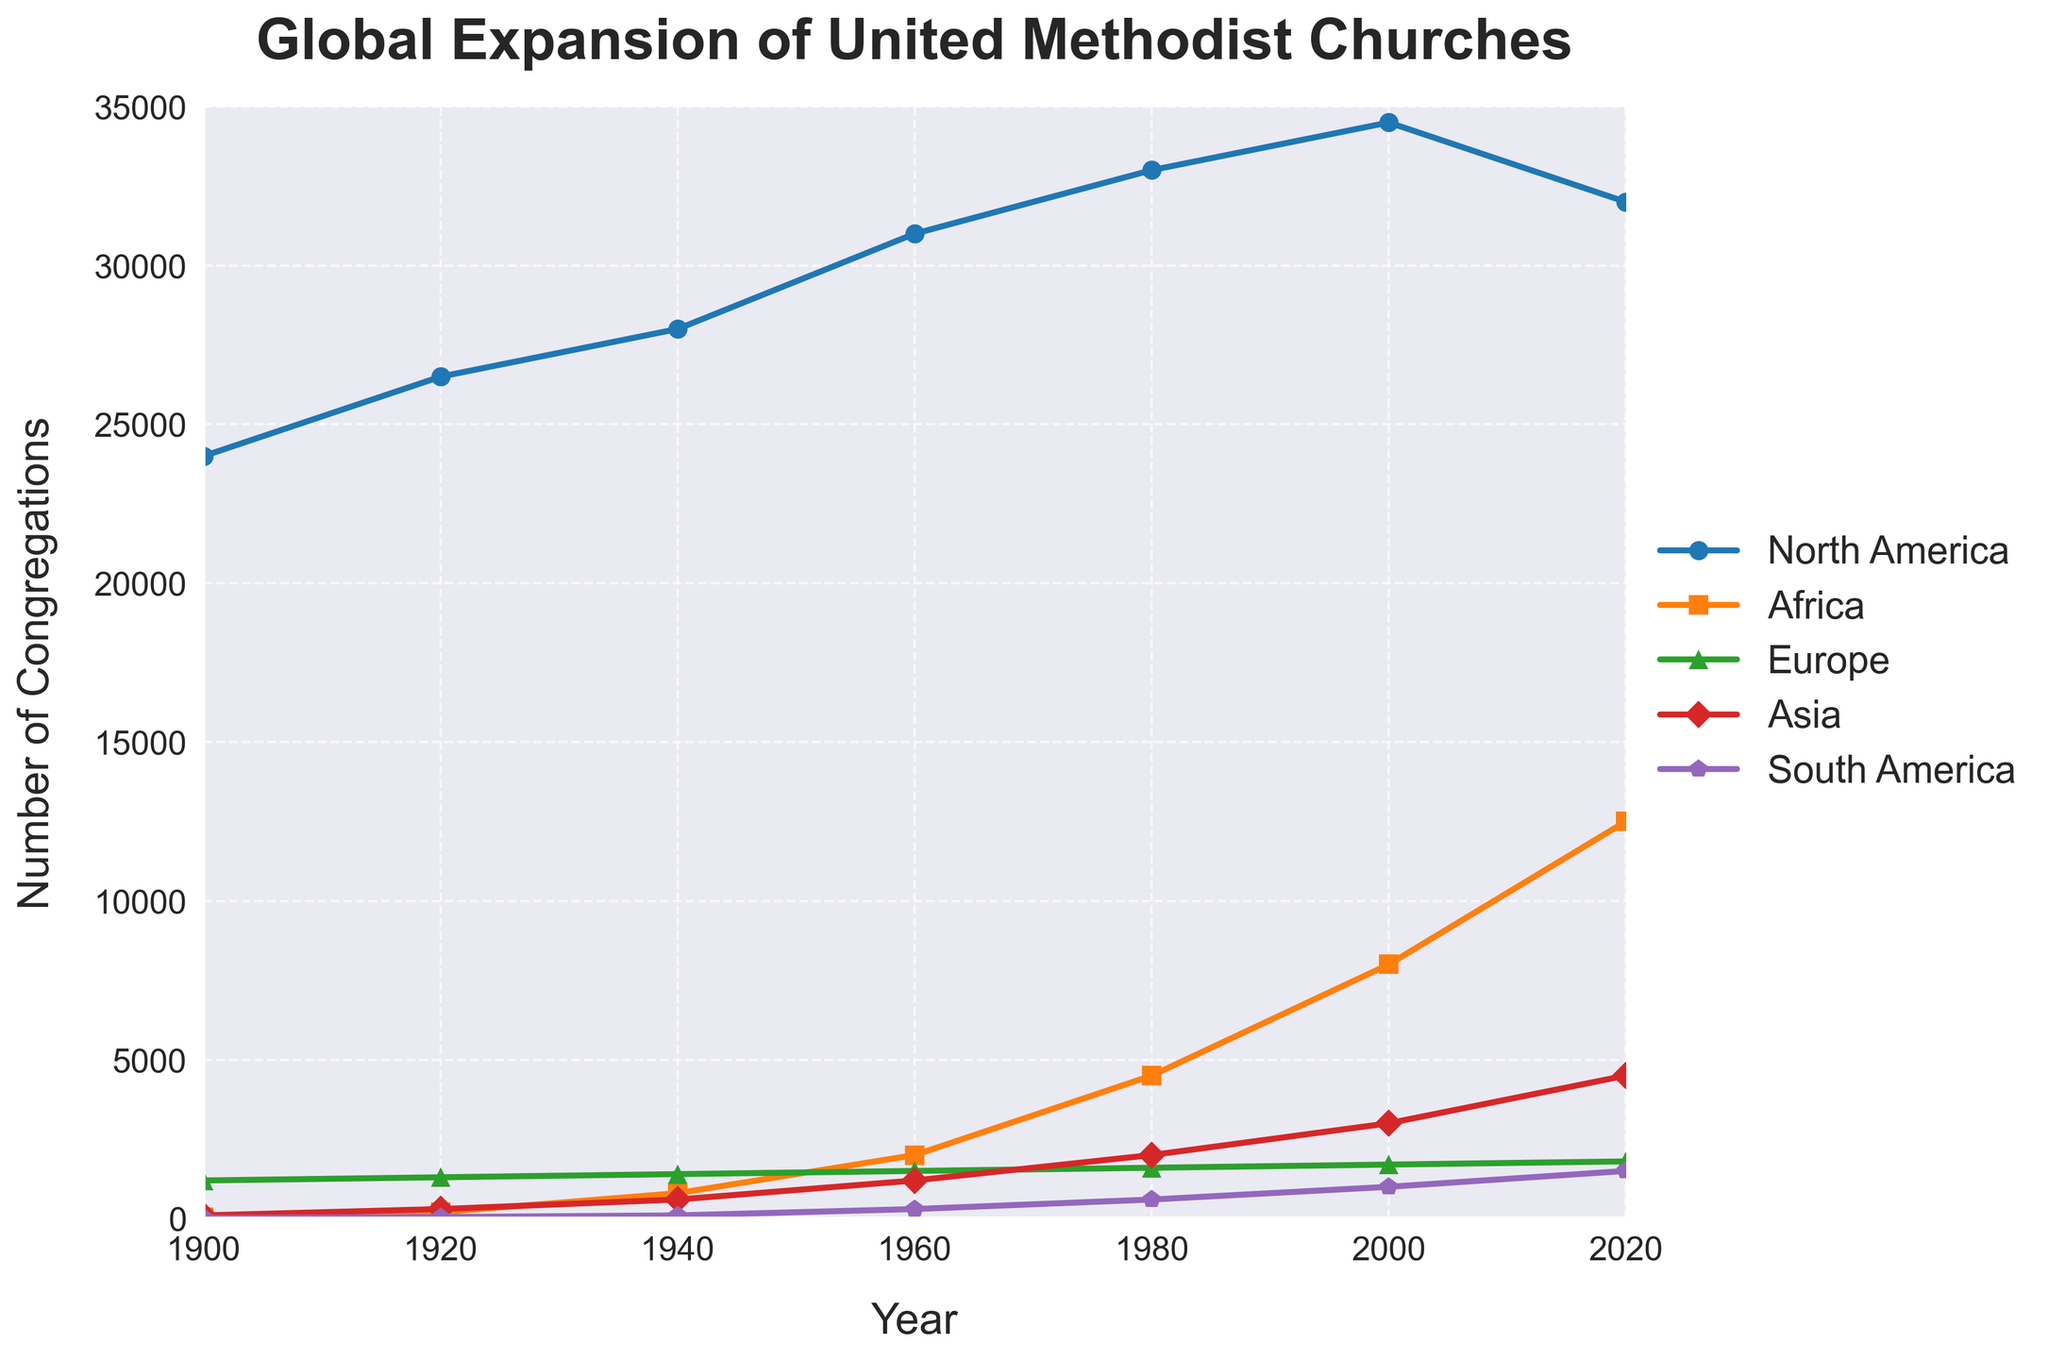What continent had the highest number of congregations in 1980? From the figure, observe the y-axis values corresponding to each continent for 1980. North America has significantly higher values compared to the other continents.
Answer: North America How many more congregations were there in Africa compared to Europe in 2000? Look at the y-axis values for Africa and Europe in 2000. Africa had around 8000 congregations, while Europe had about 1700. Subtract the number of European congregations from African congregations: 8000 - 1700 = 6300.
Answer: 6300 Which continent showed the most growth in the number of congregations from 1900 to 2020? Compare the starting and ending y-axis values for each continent. Africa showed an increase from around 50 to about 12500, indicating the largest growth.
Answer: Africa What is the difference in the number of congregations between Asia and South America in 1940? Observe the y-axis values for Asia and South America in 1940. Asia had around 600 congregations, and South America had about 100. The difference is 600 - 100 = 500.
Answer: 500 Which continent had the least number of congregations established in 1920, and how many did they have? By comparing all the y-axis values for 1920, South America had the least number of congregations, around 50.
Answer: South America, 50 What was the average number of congregations in Europe from 1900 to 2020? Add the y-axis values for Europe across all years and divide by the number of years (1200 + 1300 + 1400 + 1500 + 1600 + 1700 + 1800) / 7 ≈ 1500.
Answer: 1500 In which decade did Africa see the largest increase in the number of congregations? Calculate the differences between each decade for Africa. The largest increase is from 5450 (from 1980 to 2000: 8000 - 4500).
Answer: 1980-2000 How did the number of congregations in North America change from 2000 to 2020? Look at the y-axis values for North America in 2000 and 2020. The number decreased from around 34500 to about 32000. The change is 34500 - 32000 = 2500.
Answer: Decreased by 2500 Which two continents had the closest number of congregations in 1960? Compare the y-axis values for each continent in 1960. Europe (1500) and Asia (1200) have the closest values.
Answer: Europe and Asia 